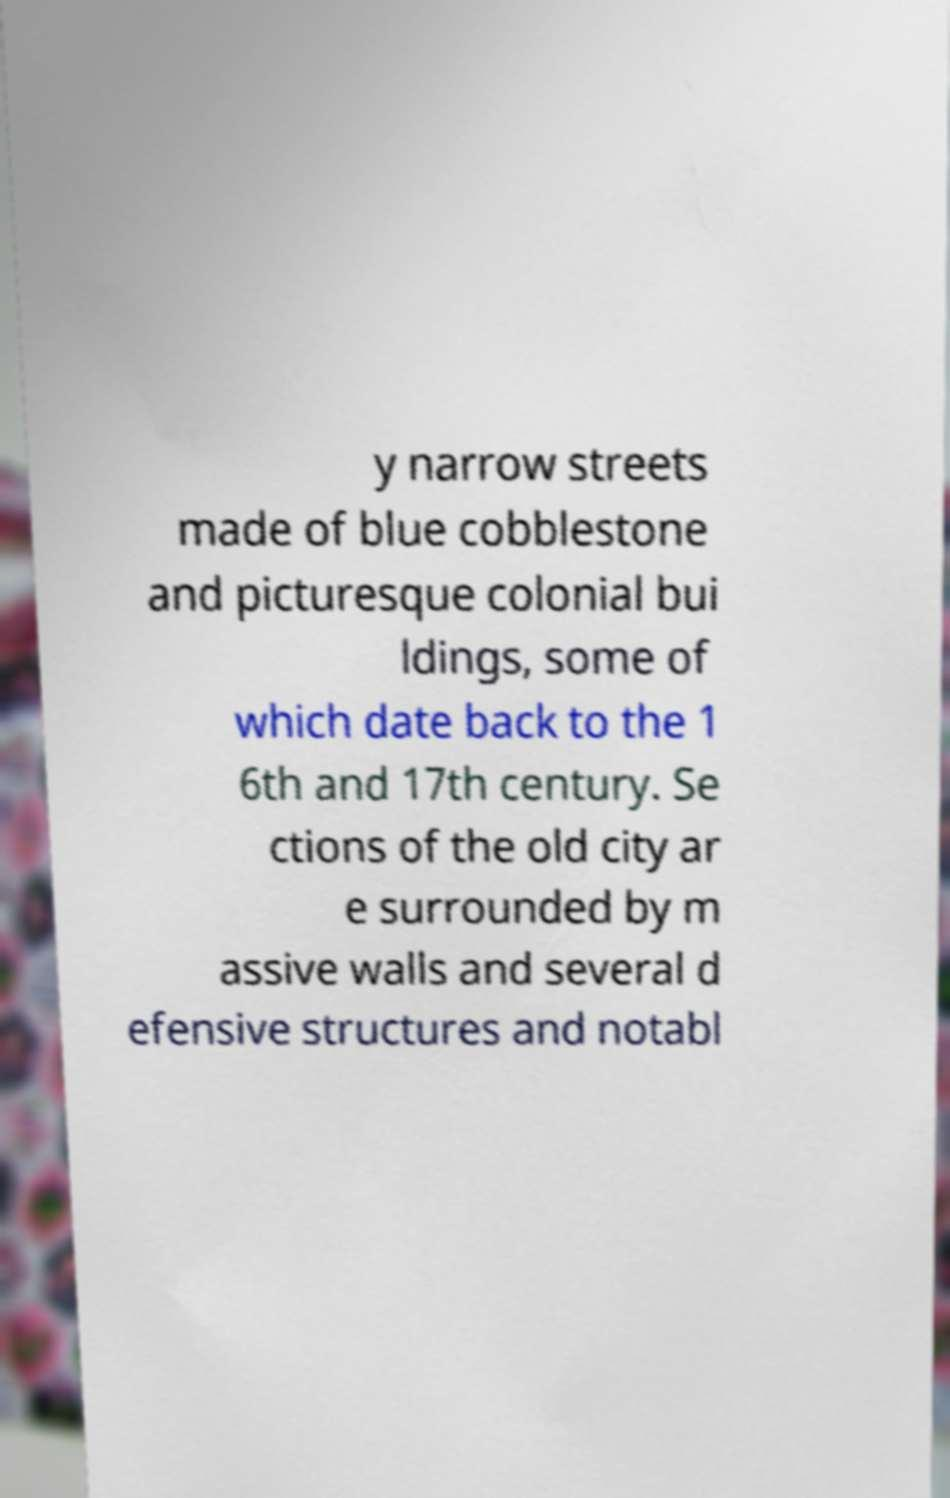Could you extract and type out the text from this image? y narrow streets made of blue cobblestone and picturesque colonial bui ldings, some of which date back to the 1 6th and 17th century. Se ctions of the old city ar e surrounded by m assive walls and several d efensive structures and notabl 